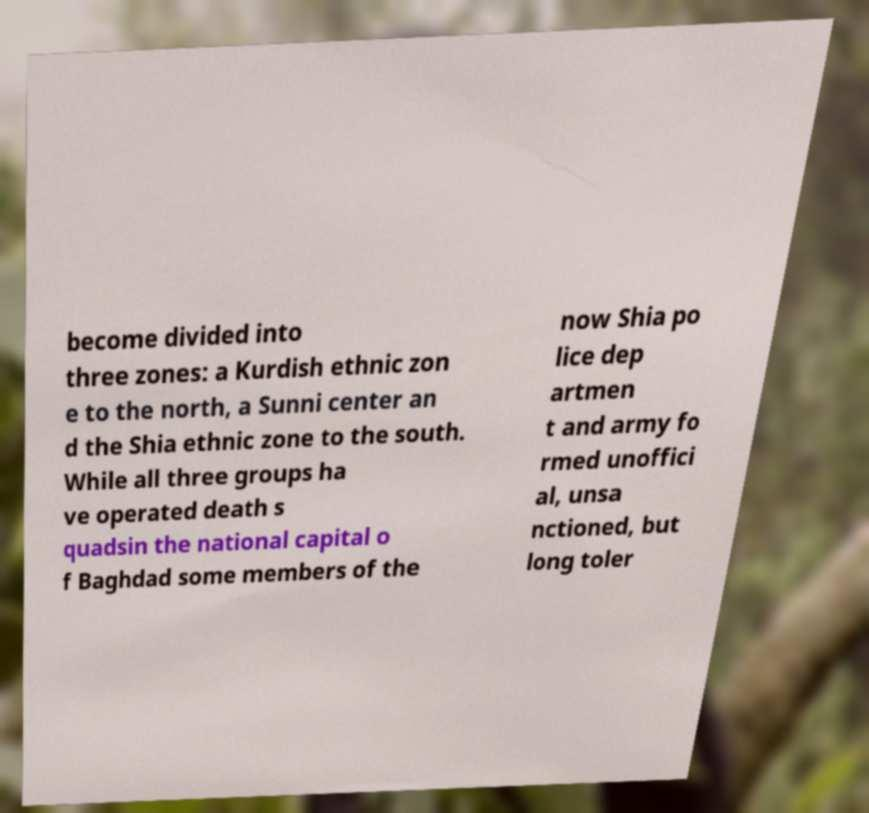What messages or text are displayed in this image? I need them in a readable, typed format. become divided into three zones: a Kurdish ethnic zon e to the north, a Sunni center an d the Shia ethnic zone to the south. While all three groups ha ve operated death s quadsin the national capital o f Baghdad some members of the now Shia po lice dep artmen t and army fo rmed unoffici al, unsa nctioned, but long toler 